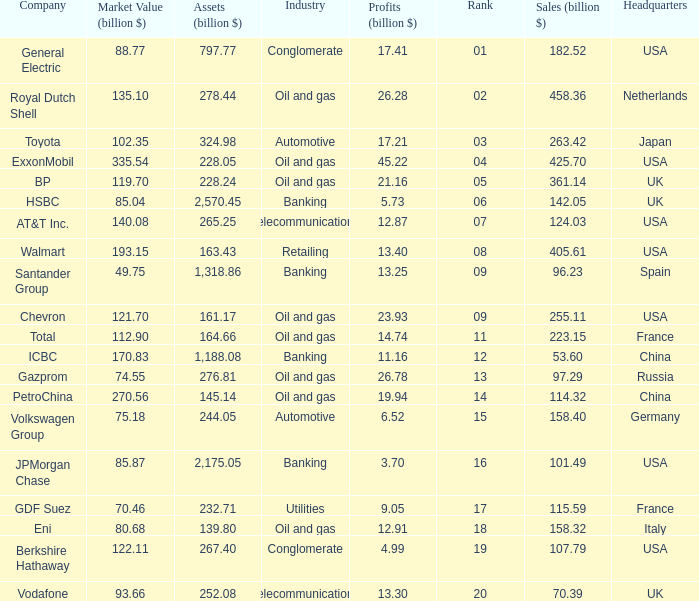Could you parse the entire table as a dict? {'header': ['Company', 'Market Value (billion $)', 'Assets (billion $)', 'Industry', 'Profits (billion $)', 'Rank', 'Sales (billion $)', 'Headquarters'], 'rows': [['General Electric', '88.77', '797.77', 'Conglomerate', '17.41', '01', '182.52', 'USA'], ['Royal Dutch Shell', '135.10', '278.44', 'Oil and gas', '26.28', '02', '458.36', 'Netherlands'], ['Toyota', '102.35', '324.98', 'Automotive', '17.21', '03', '263.42', 'Japan'], ['ExxonMobil', '335.54', '228.05', 'Oil and gas', '45.22', '04', '425.70', 'USA'], ['BP', '119.70', '228.24', 'Oil and gas', '21.16', '05', '361.14', 'UK'], ['HSBC', '85.04', '2,570.45', 'Banking', '5.73', '06', '142.05', 'UK'], ['AT&T Inc.', '140.08', '265.25', 'Telecommunications', '12.87', '07', '124.03', 'USA'], ['Walmart', '193.15', '163.43', 'Retailing', '13.40', '08', '405.61', 'USA'], ['Santander Group', '49.75', '1,318.86', 'Banking', '13.25', '09', '96.23', 'Spain'], ['Chevron', '121.70', '161.17', 'Oil and gas', '23.93', '09', '255.11', 'USA'], ['Total', '112.90', '164.66', 'Oil and gas', '14.74', '11', '223.15', 'France'], ['ICBC', '170.83', '1,188.08', 'Banking', '11.16', '12', '53.60', 'China'], ['Gazprom', '74.55', '276.81', 'Oil and gas', '26.78', '13', '97.29', 'Russia'], ['PetroChina', '270.56', '145.14', 'Oil and gas', '19.94', '14', '114.32', 'China'], ['Volkswagen Group', '75.18', '244.05', 'Automotive', '6.52', '15', '158.40', 'Germany'], ['JPMorgan Chase', '85.87', '2,175.05', 'Banking', '3.70', '16', '101.49', 'USA'], ['GDF Suez', '70.46', '232.71', 'Utilities', '9.05', '17', '115.59', 'France'], ['Eni', '80.68', '139.80', 'Oil and gas', '12.91', '18', '158.32', 'Italy'], ['Berkshire Hathaway', '122.11', '267.40', 'Conglomerate', '4.99', '19', '107.79', 'USA'], ['Vodafone', '93.66', '252.08', 'Telecommunications', '13.30', '20', '70.39', 'UK']]} How many Assets (billion $) has an Industry of oil and gas, and a Rank of 9, and a Market Value (billion $) larger than 121.7? None. 